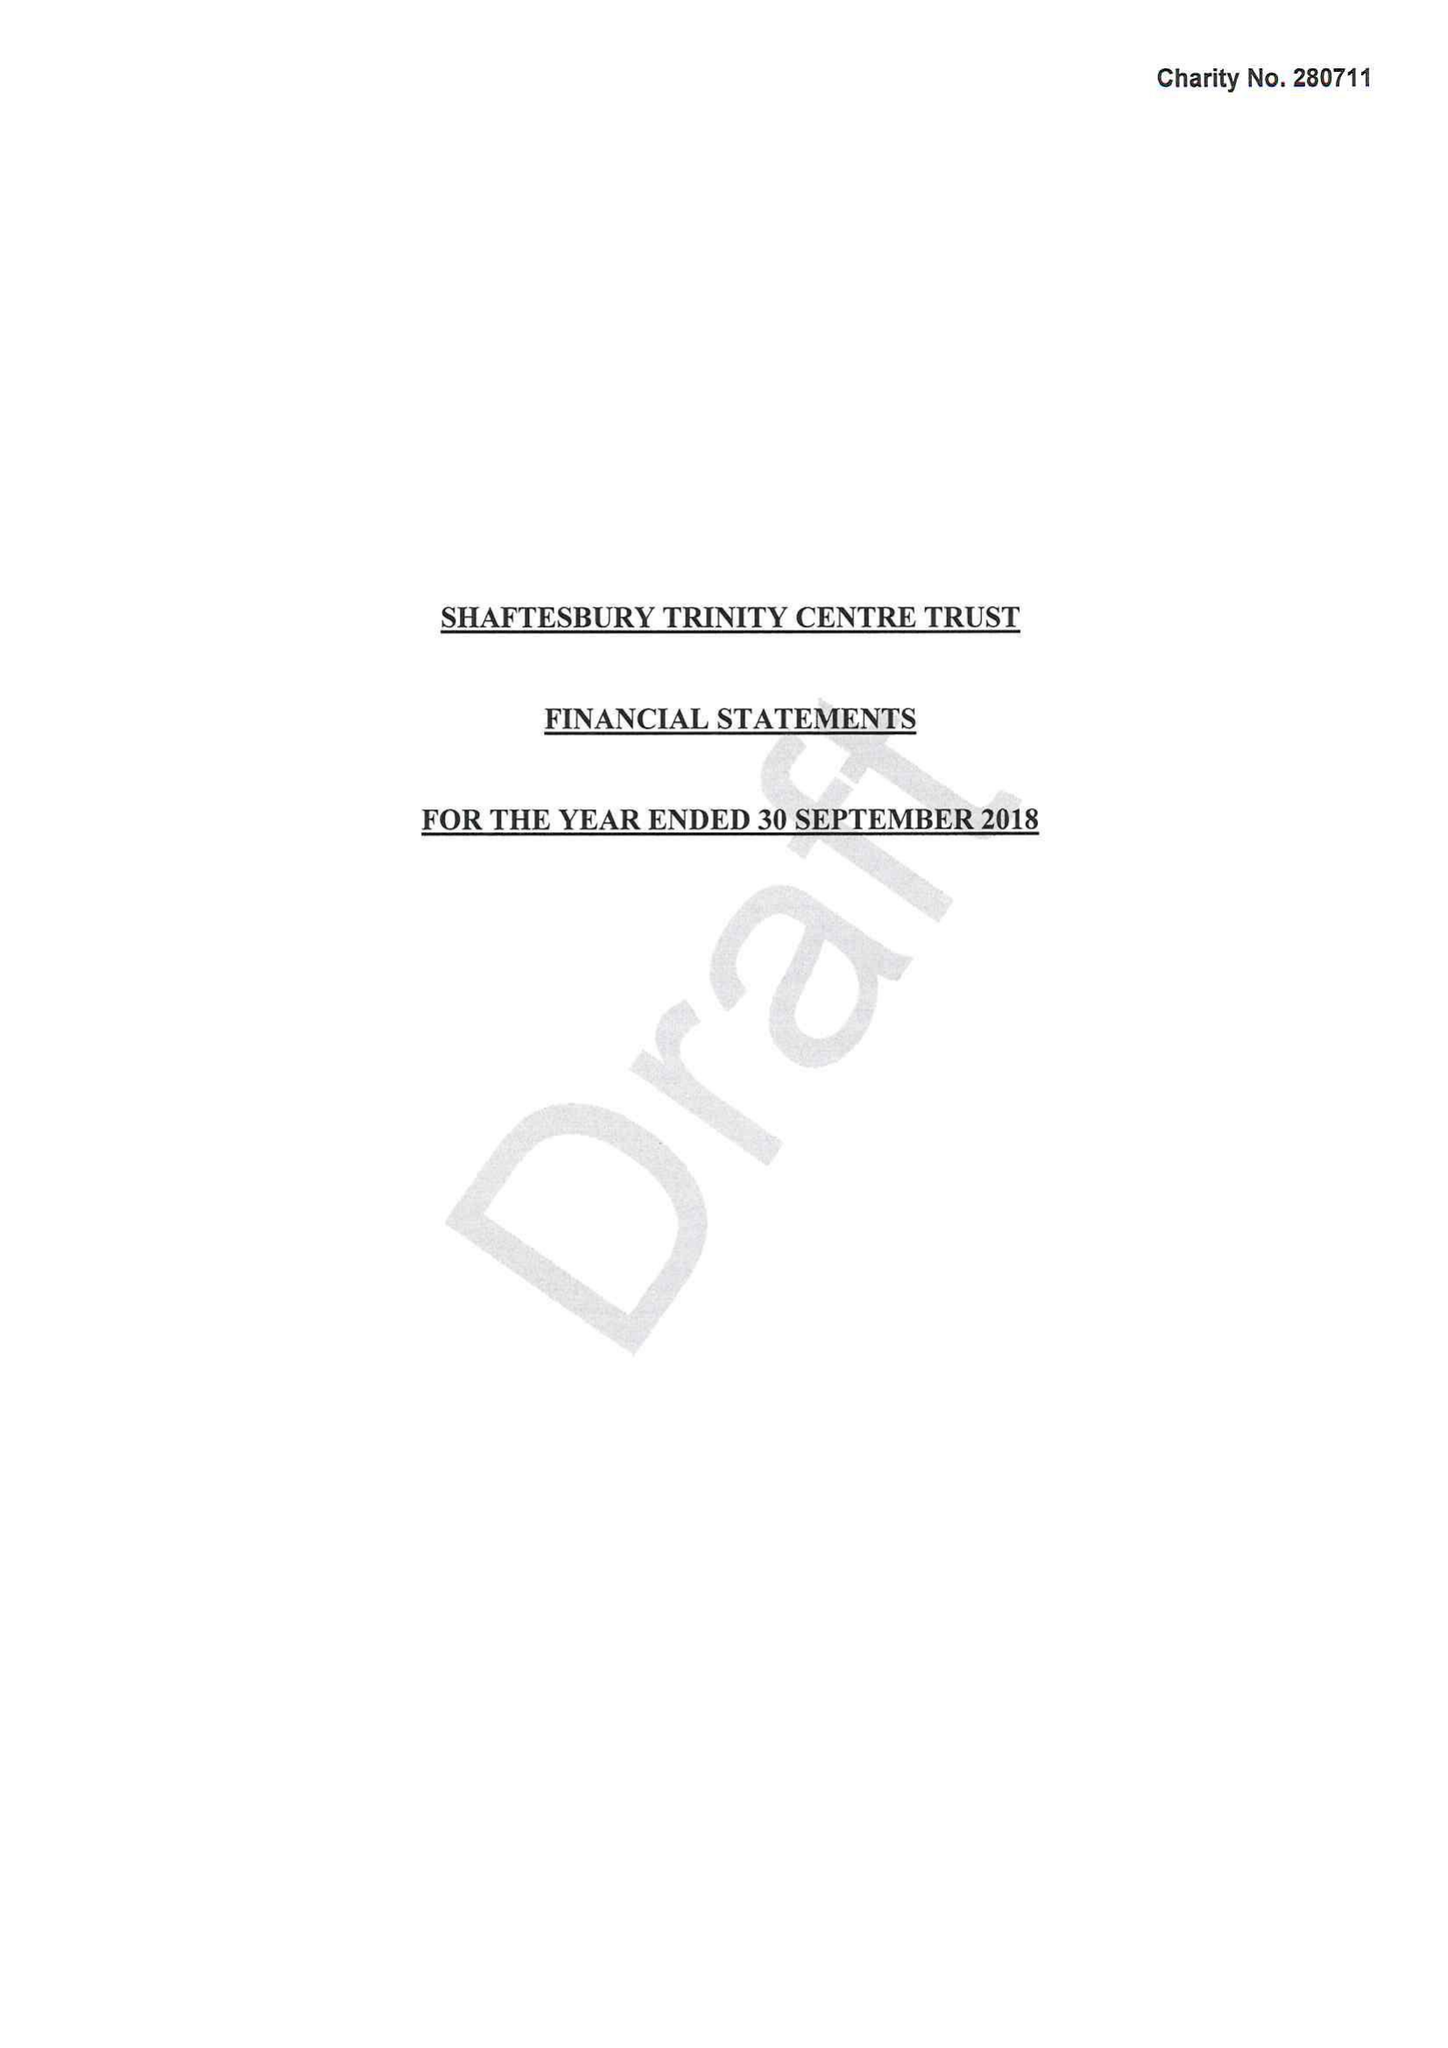What is the value for the spending_annually_in_british_pounds?
Answer the question using a single word or phrase. 159907.00 